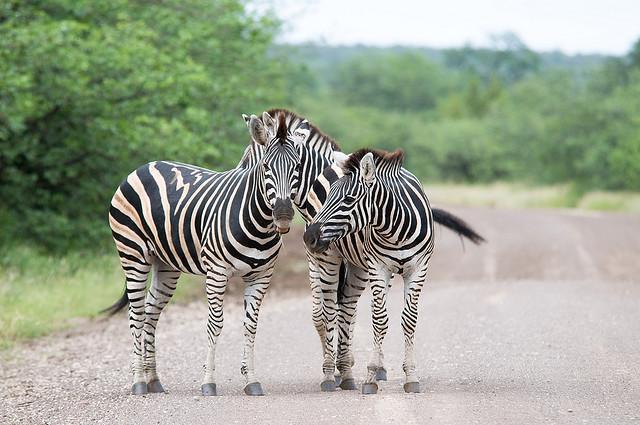What part of this photo would these animals never encounter in their natural habitat?
Answer the question by selecting the correct answer among the 4 following choices and explain your choice with a short sentence. The answer should be formatted with the following format: `Answer: choice
Rationale: rationale.`
Options: Trees, each other, grass, pavement. Answer: pavement.
Rationale: The pavement is manmade. 